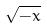Convert formula to latex. <formula><loc_0><loc_0><loc_500><loc_500>\sqrt { - x }</formula> 